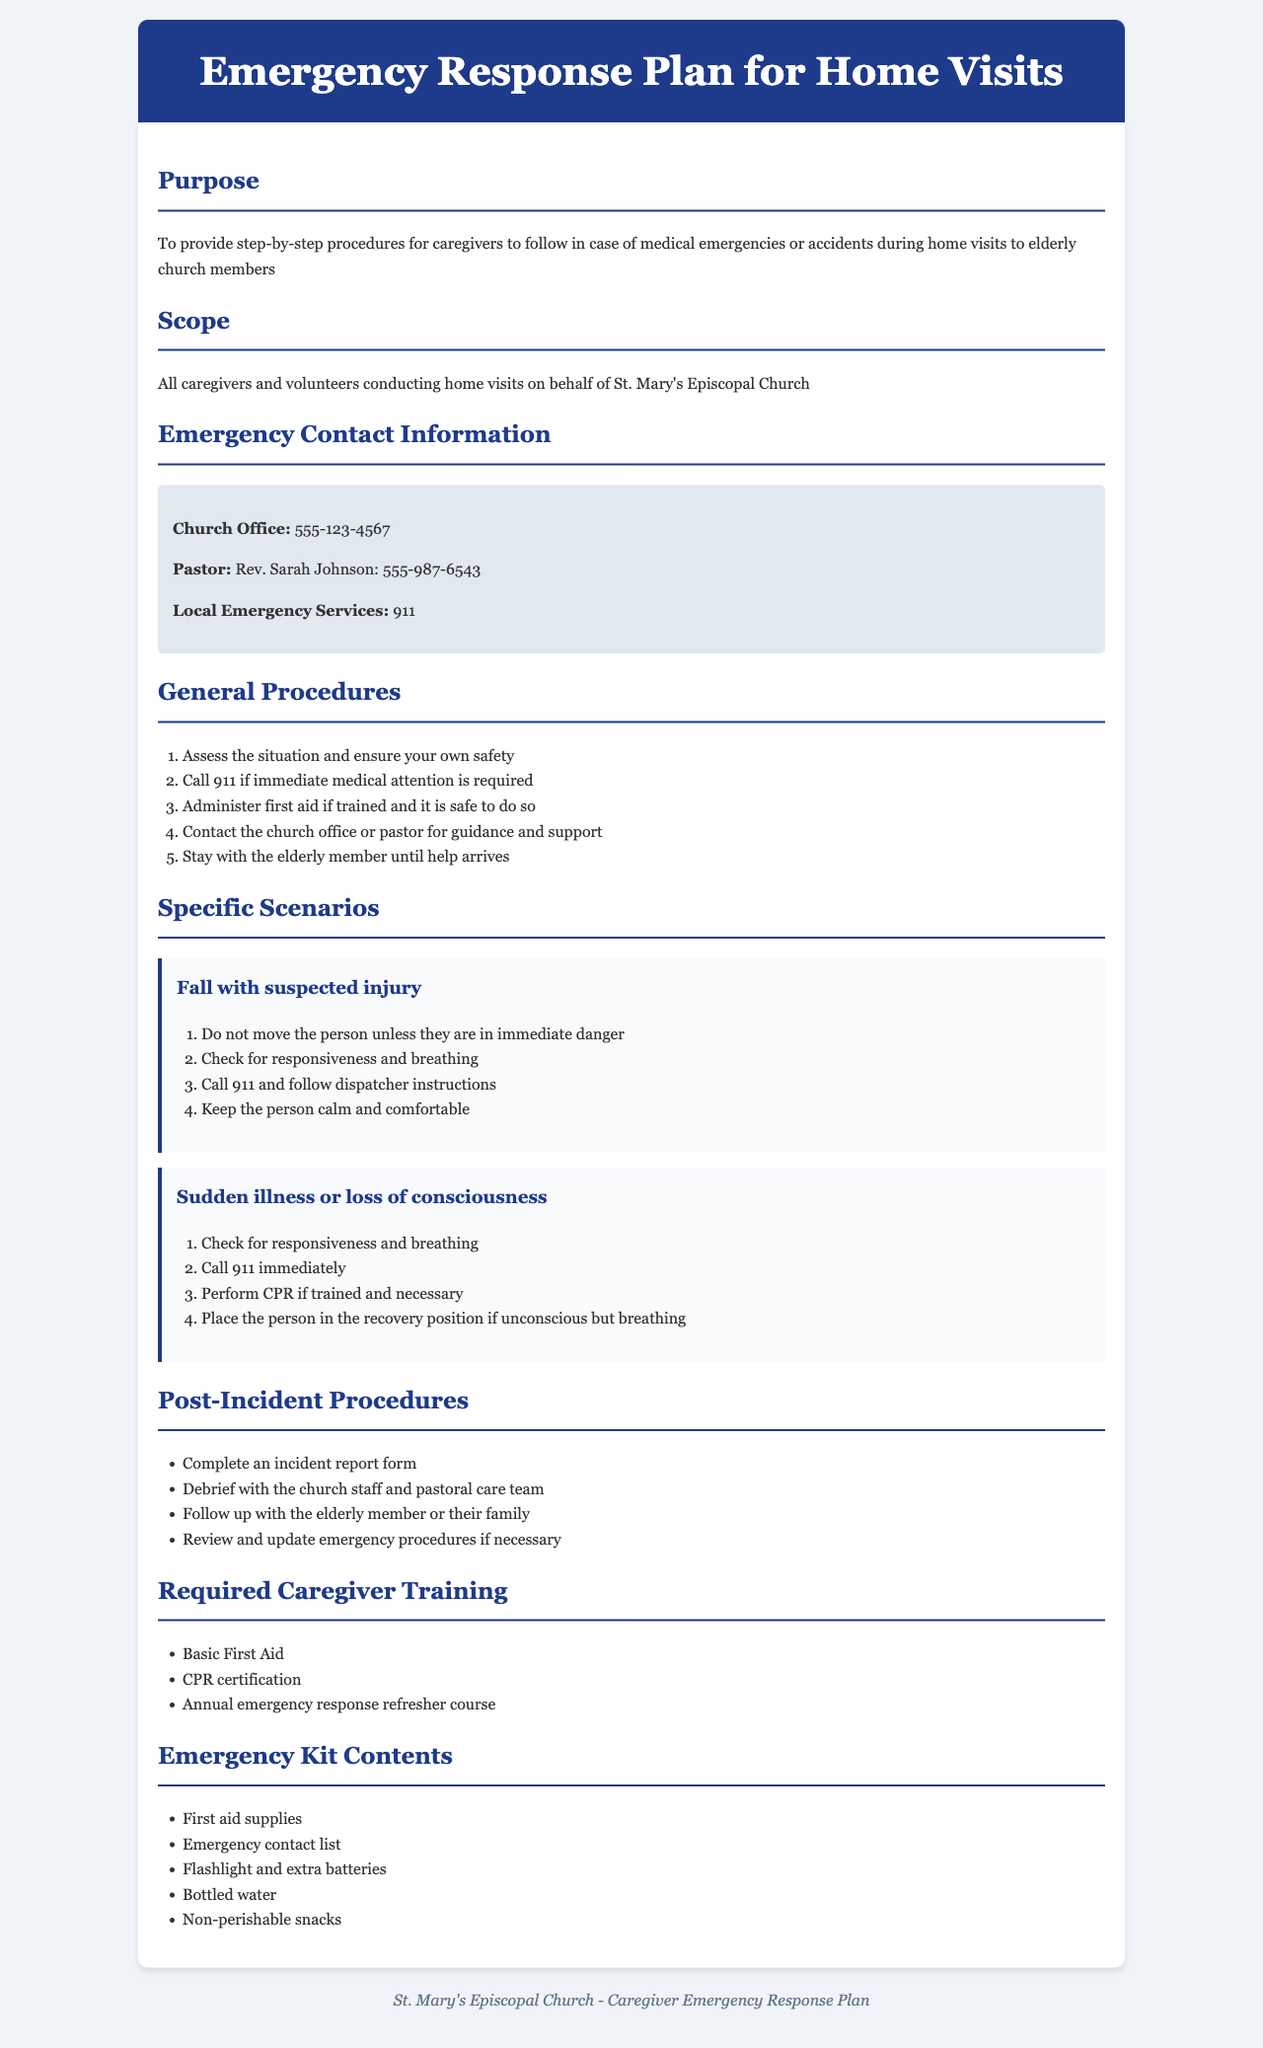What is the purpose of the plan? The purpose is to provide step-by-step procedures for caregivers to follow in case of medical emergencies or accidents during home visits to elderly church members.
Answer: To provide step-by-step procedures for caregivers to follow in case of medical emergencies or accidents during home visits to elderly church members Who should follow the emergency response plan? The scope indicates that it applies to all caregivers and volunteers conducting home visits on behalf of St. Mary's Episcopal Church.
Answer: All caregivers and volunteers conducting home visits on behalf of St. Mary's Episcopal Church What situation requires calling 911? The general procedures state to call 911 if immediate medical attention is required.
Answer: Immediate medical attention is required What should caregivers do after an incident? The post-incident procedures list completing an incident report form as the first step.
Answer: Complete an incident report form What training is required for caregivers? The required caregiver training includes basic first aid.
Answer: Basic First Aid How should caregivers respond to a fall with suspected injury? They should not move the person unless they are in immediate danger.
Answer: Do not move the person unless they are in immediate danger Who do caregivers contact for guidance during an emergency? Caregivers are instructed to contact the church office or pastor for guidance and support.
Answer: The church office or pastor What should be included in the emergency kit? First aid supplies must be included in the emergency kit contents.
Answer: First aid supplies 